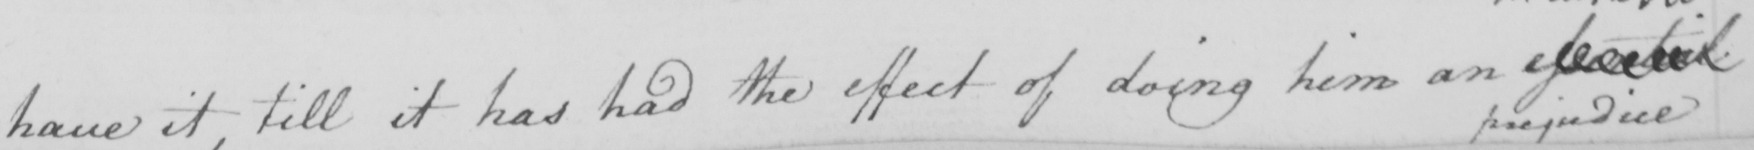What does this handwritten line say? have it , till it has had the effect of doing him an essential 